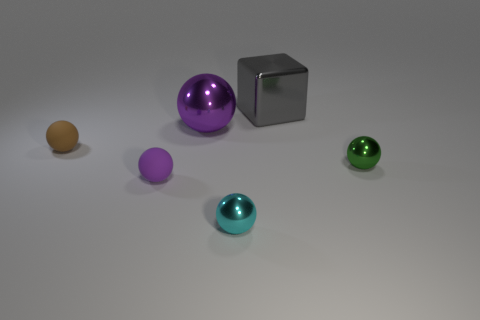Subtract all cyan balls. How many balls are left? 4 Subtract 1 spheres. How many spheres are left? 4 Subtract all yellow balls. Subtract all red cylinders. How many balls are left? 5 Add 1 big gray cubes. How many objects exist? 7 Subtract all cubes. How many objects are left? 5 Add 5 purple shiny things. How many purple shiny things are left? 6 Add 2 large green matte objects. How many large green matte objects exist? 2 Subtract 0 cyan blocks. How many objects are left? 6 Subtract all metal blocks. Subtract all gray shiny blocks. How many objects are left? 4 